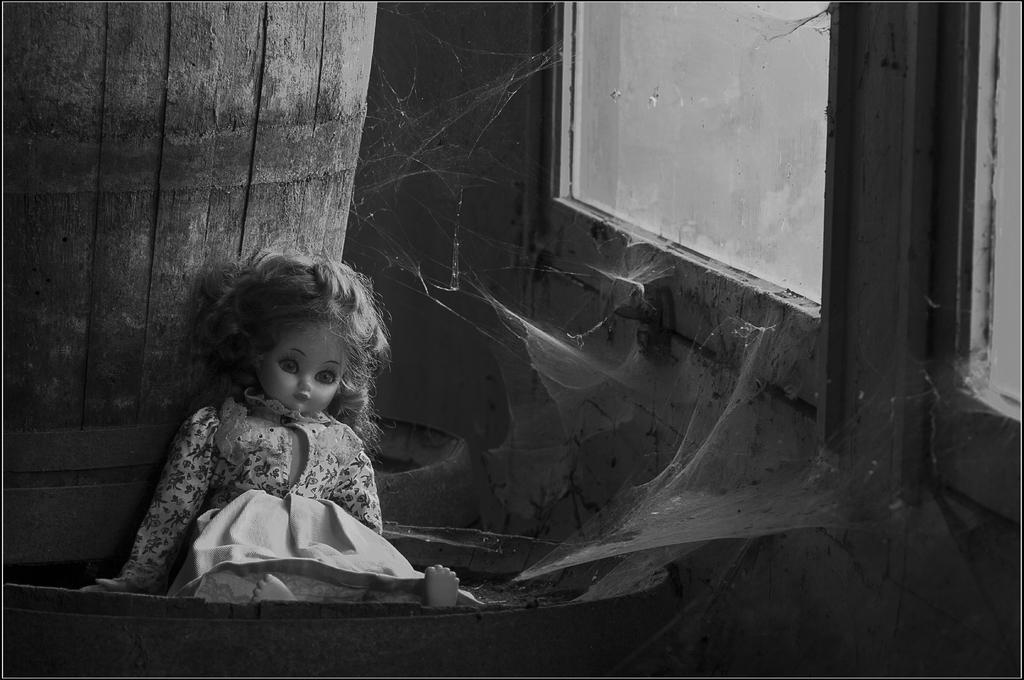How would you summarize this image in a sentence or two? This is a black and white pic. Here we can see a doll in a sitting position on a barrel and leaning to the another panel and on the right side we can see glass,door and wall. 